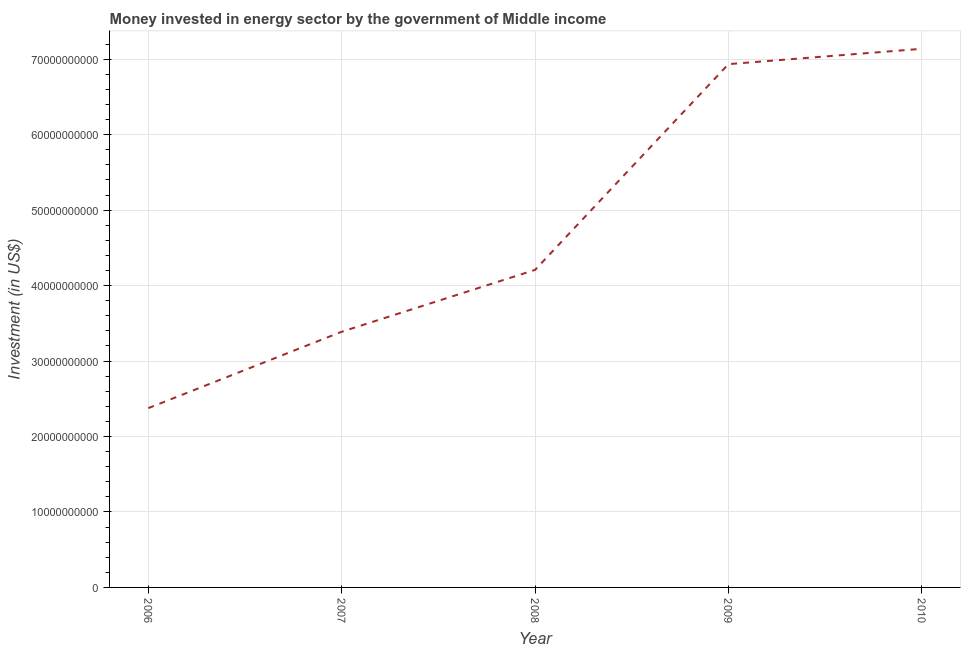What is the investment in energy in 2006?
Your answer should be compact. 2.38e+1. Across all years, what is the maximum investment in energy?
Your response must be concise. 7.14e+1. Across all years, what is the minimum investment in energy?
Ensure brevity in your answer.  2.38e+1. What is the sum of the investment in energy?
Ensure brevity in your answer.  2.40e+11. What is the difference between the investment in energy in 2009 and 2010?
Make the answer very short. -2.03e+09. What is the average investment in energy per year?
Provide a succinct answer. 4.81e+1. What is the median investment in energy?
Ensure brevity in your answer.  4.21e+1. In how many years, is the investment in energy greater than 32000000000 US$?
Ensure brevity in your answer.  4. What is the ratio of the investment in energy in 2007 to that in 2009?
Your answer should be compact. 0.49. Is the investment in energy in 2008 less than that in 2010?
Offer a terse response. Yes. Is the difference between the investment in energy in 2007 and 2008 greater than the difference between any two years?
Provide a short and direct response. No. What is the difference between the highest and the second highest investment in energy?
Your response must be concise. 2.03e+09. Is the sum of the investment in energy in 2007 and 2009 greater than the maximum investment in energy across all years?
Your answer should be very brief. Yes. What is the difference between the highest and the lowest investment in energy?
Make the answer very short. 4.76e+1. Does the investment in energy monotonically increase over the years?
Give a very brief answer. Yes. How many lines are there?
Your response must be concise. 1. How many years are there in the graph?
Make the answer very short. 5. What is the difference between two consecutive major ticks on the Y-axis?
Offer a very short reply. 1.00e+1. Are the values on the major ticks of Y-axis written in scientific E-notation?
Offer a terse response. No. Does the graph contain grids?
Make the answer very short. Yes. What is the title of the graph?
Ensure brevity in your answer.  Money invested in energy sector by the government of Middle income. What is the label or title of the X-axis?
Your response must be concise. Year. What is the label or title of the Y-axis?
Provide a short and direct response. Investment (in US$). What is the Investment (in US$) in 2006?
Offer a terse response. 2.38e+1. What is the Investment (in US$) in 2007?
Offer a very short reply. 3.39e+1. What is the Investment (in US$) of 2008?
Ensure brevity in your answer.  4.21e+1. What is the Investment (in US$) in 2009?
Your answer should be compact. 6.94e+1. What is the Investment (in US$) of 2010?
Provide a short and direct response. 7.14e+1. What is the difference between the Investment (in US$) in 2006 and 2007?
Offer a very short reply. -1.01e+1. What is the difference between the Investment (in US$) in 2006 and 2008?
Ensure brevity in your answer.  -1.83e+1. What is the difference between the Investment (in US$) in 2006 and 2009?
Provide a succinct answer. -4.56e+1. What is the difference between the Investment (in US$) in 2006 and 2010?
Keep it short and to the point. -4.76e+1. What is the difference between the Investment (in US$) in 2007 and 2008?
Provide a succinct answer. -8.20e+09. What is the difference between the Investment (in US$) in 2007 and 2009?
Give a very brief answer. -3.55e+1. What is the difference between the Investment (in US$) in 2007 and 2010?
Make the answer very short. -3.75e+1. What is the difference between the Investment (in US$) in 2008 and 2009?
Provide a short and direct response. -2.73e+1. What is the difference between the Investment (in US$) in 2008 and 2010?
Provide a short and direct response. -2.93e+1. What is the difference between the Investment (in US$) in 2009 and 2010?
Provide a short and direct response. -2.03e+09. What is the ratio of the Investment (in US$) in 2006 to that in 2007?
Your answer should be very brief. 0.7. What is the ratio of the Investment (in US$) in 2006 to that in 2008?
Provide a short and direct response. 0.56. What is the ratio of the Investment (in US$) in 2006 to that in 2009?
Your answer should be compact. 0.34. What is the ratio of the Investment (in US$) in 2006 to that in 2010?
Ensure brevity in your answer.  0.33. What is the ratio of the Investment (in US$) in 2007 to that in 2008?
Make the answer very short. 0.81. What is the ratio of the Investment (in US$) in 2007 to that in 2009?
Keep it short and to the point. 0.49. What is the ratio of the Investment (in US$) in 2007 to that in 2010?
Your answer should be compact. 0.47. What is the ratio of the Investment (in US$) in 2008 to that in 2009?
Ensure brevity in your answer.  0.61. What is the ratio of the Investment (in US$) in 2008 to that in 2010?
Offer a terse response. 0.59. What is the ratio of the Investment (in US$) in 2009 to that in 2010?
Your answer should be very brief. 0.97. 